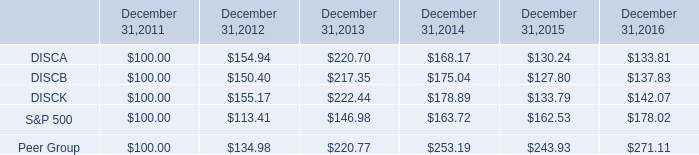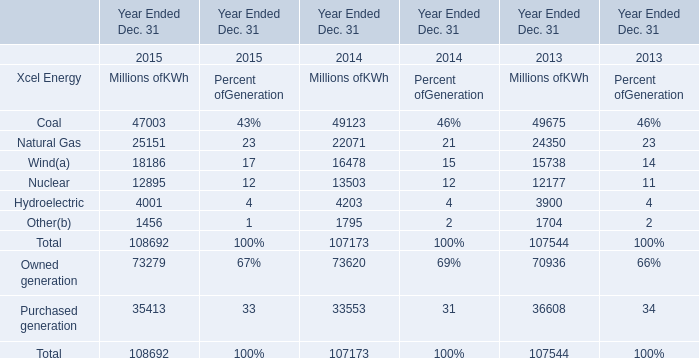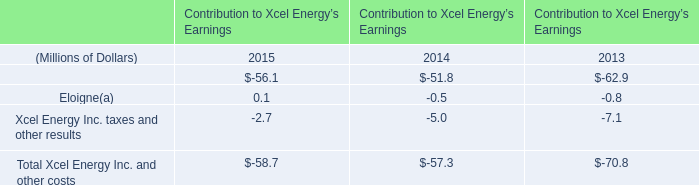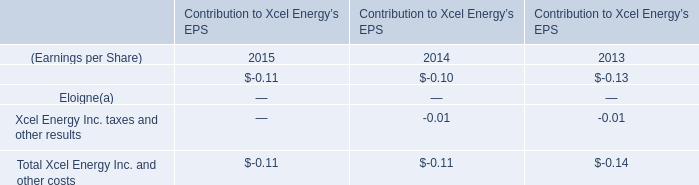What's the sum of all Xcel energy that are greater than 20000 in 2015? (in million) 
Computations: (47003 + 25151)
Answer: 72154.0. 